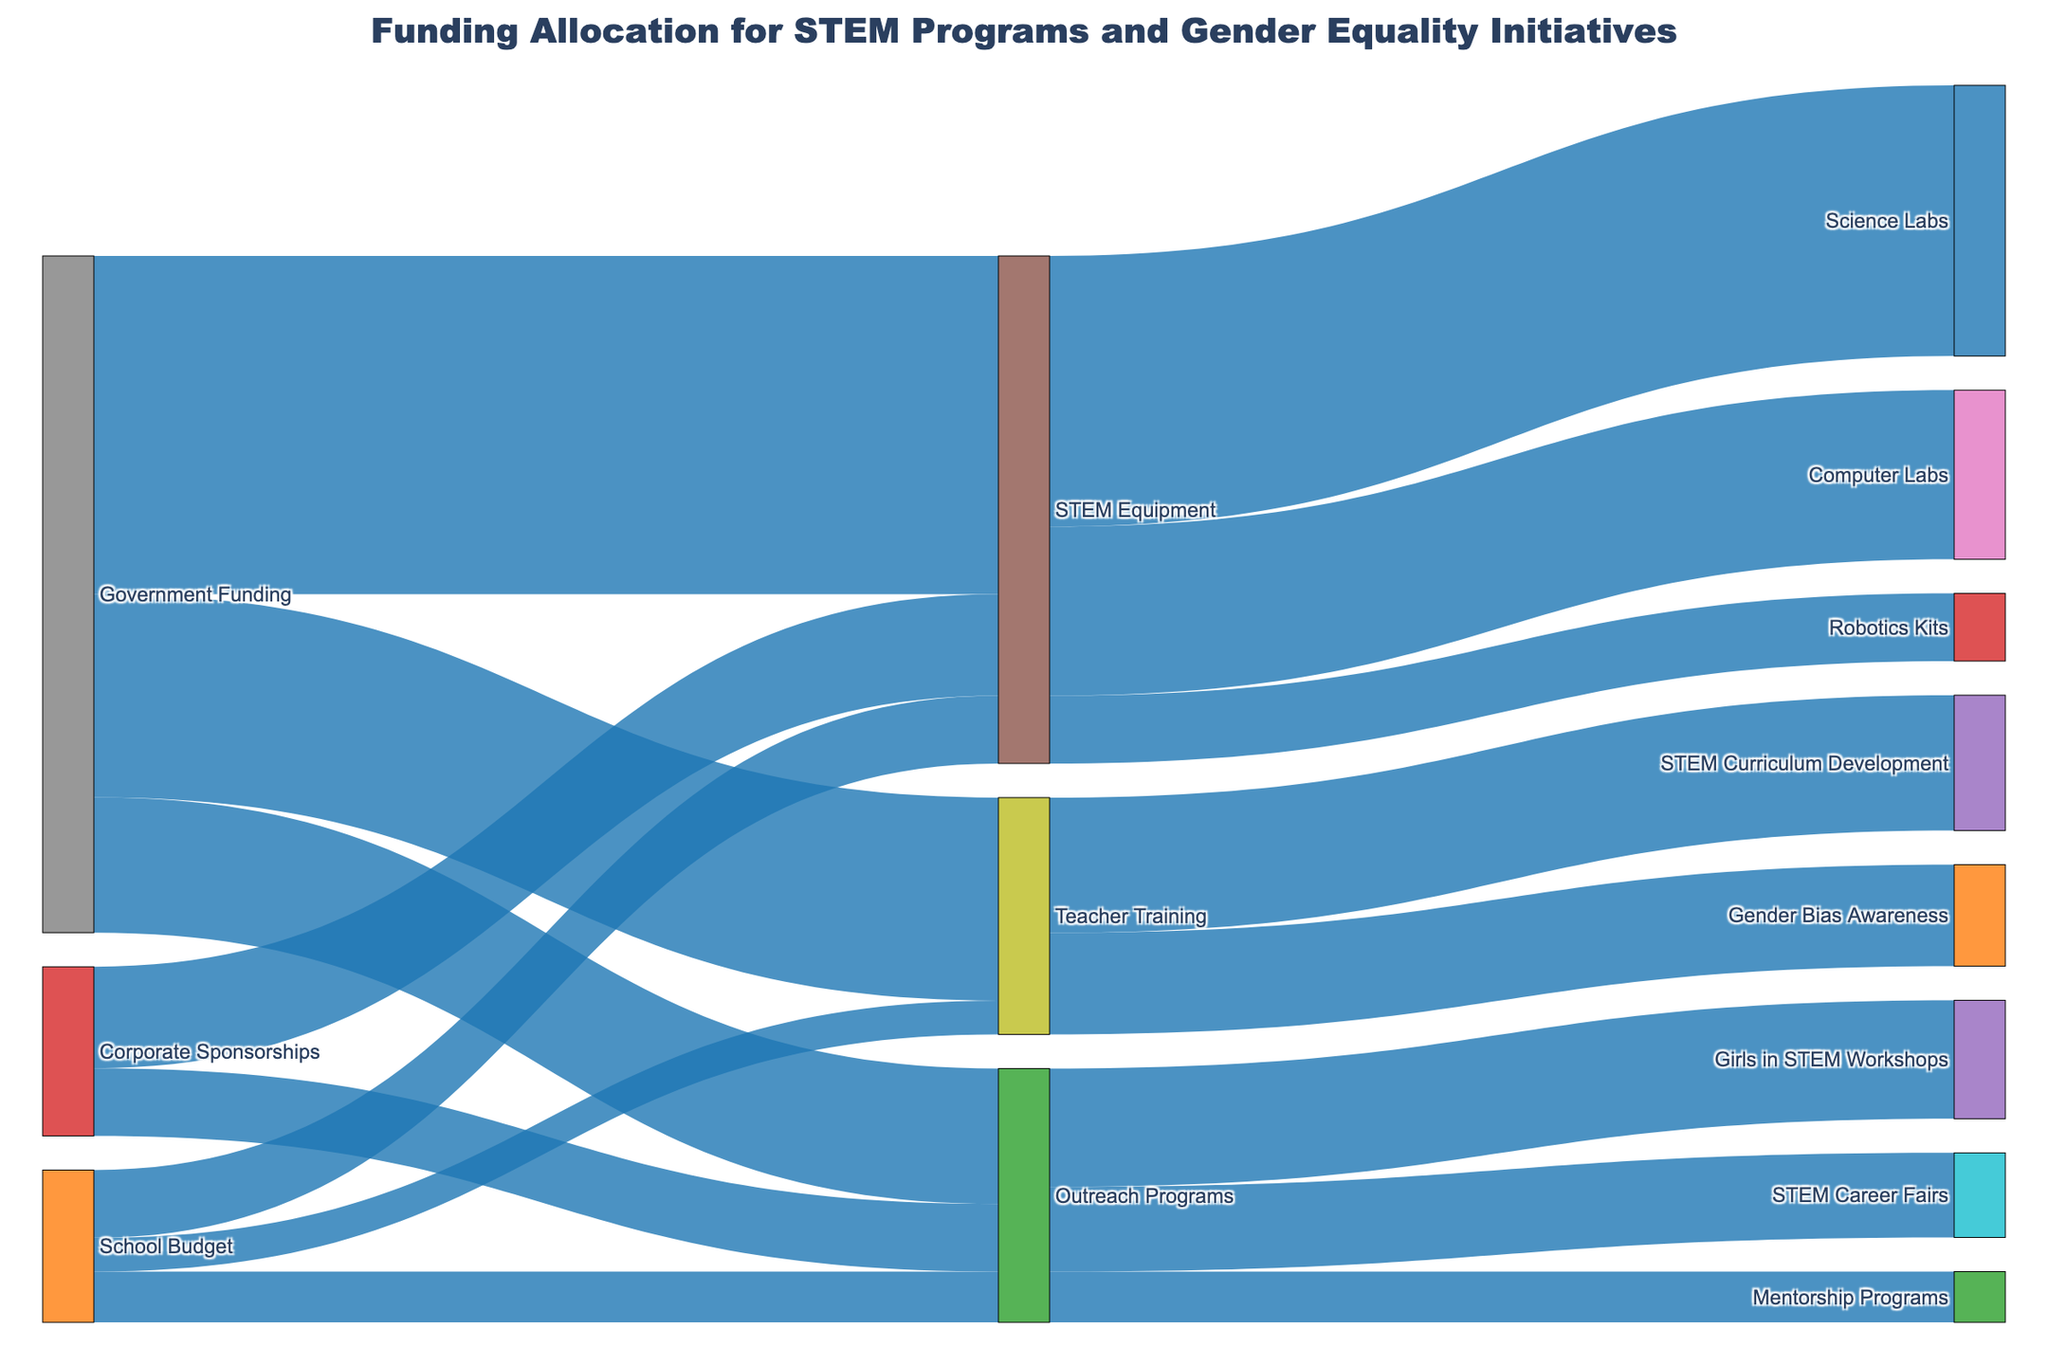What is the total government funding for STEM programs and gender equality initiatives in the schools? Add up the values allocated from Government Funding to each target: 500,000 (STEM Equipment) + 300,000 (Teacher Training) + 200,000 (Outreach Programs).
Answer: 1,000,000 How much funding does STEM Equipment receive from all sources combined? Add the values allocated to STEM Equipment from Government Funding, School Budget, and Corporate Sponsorships: 500,000 + 100,000 + 150,000.
Answer: 750,000 What is the comparitive funding received for Teacher Training versus Outreach Programs from the school budget? Compare the allocated values from School Budget: Teacher Training (50,000) and Outreach Programs (75,000).
Answer: Outreach Programs receive 25,000 more than Teacher Training How much is allocated to Science Labs from STEM Equipment? Find the value corresponding to STEM Equipment -> Science Labs.
Answer: 400,000 How does Gender Bias Awareness training funding compare to that for STEM Curriculum Development? Compare the values allocated from Teacher Training to Gender Bias Awareness (150,000) and STEM Curriculum Development (200,000).
Answer: STEM Curriculum Development receives 50,000 more Which initiative receives the most funding under Outreach Programs? Identify the target under Outreach Programs with the highest value: Girls in STEM Workshops (175,000), STEM Career Fairs (125,000), Mentorship Programs (75,000).
Answer: Girls in STEM Workshops What is the combined funding for STEM Career Fairs and Mentorship Programs? Sum the values allocated for STEM Career Fairs (125,000) and Mentorship Programs (75,000).
Answer: 200,000 Does the government provide more funding to Teacher Training or Corporate Sponsorships to Outreach Programs? Compare the values allocated from Government Funding to Teacher Training (300,000) and from Corporate Sponsorships to Outreach Programs (100,000).
Answer: Teacher Training receives more What is the predominant source of funding for STEM Equipment? Compare the values allocated to STEM Equipment from Government Funding (500,000), School Budget (100,000), and Corporate Sponsorships (150,000).
Answer: Government Funding Which specific initiative, under Outreach Programs, receives the least funding? Compare the funding values for Girls in STEM Workshops (175,000), STEM Career Fairs (125,000), and Mentorship Programs (75,000).
Answer: Mentorship Programs 